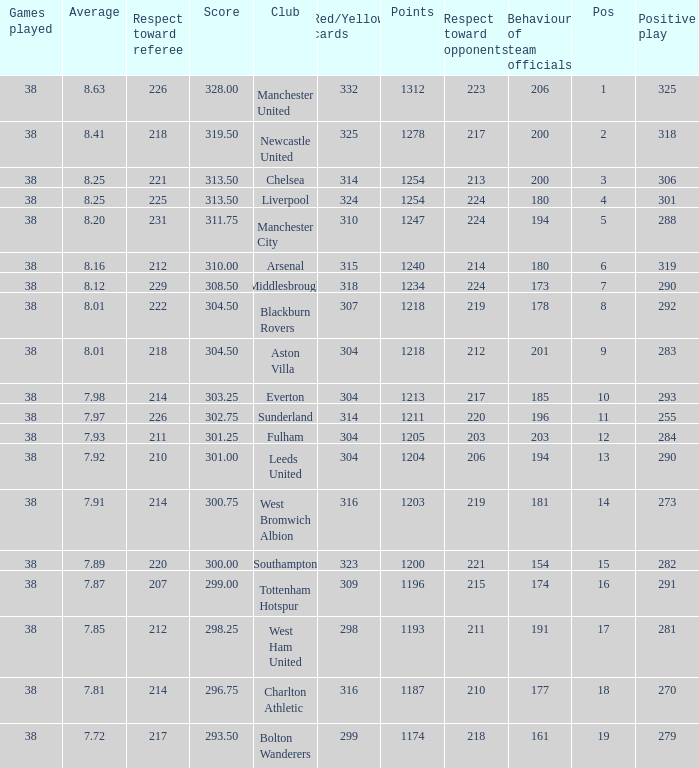Name the points for 212 respect toward opponents 1218.0. 